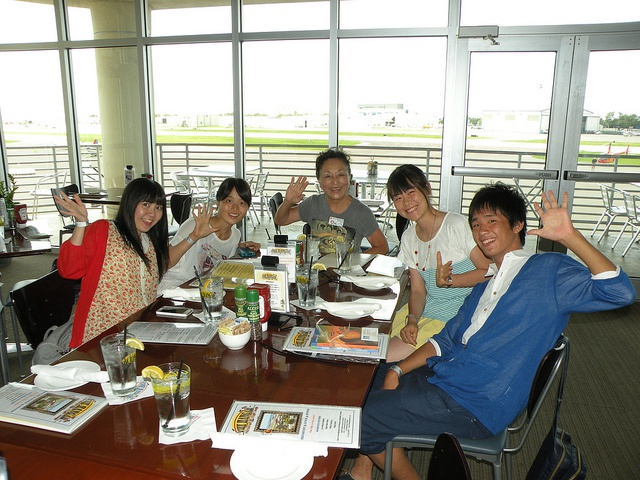Describe the objects in this image and their specific colors. I can see dining table in white, maroon, ivory, black, and darkgray tones, people in white, blue, black, and navy tones, people in white, brown, black, tan, and gray tones, people in white, gray, darkgray, lightgray, and tan tones, and chair in white, black, gray, and purple tones in this image. 